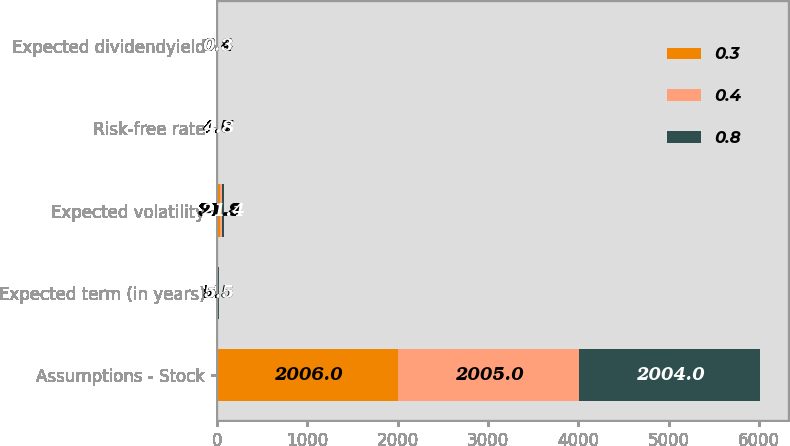Convert chart. <chart><loc_0><loc_0><loc_500><loc_500><stacked_bar_chart><ecel><fcel>Assumptions - Stock<fcel>Expected term (in years)<fcel>Expected volatility<fcel>Risk-free rate<fcel>Expected dividendyield<nl><fcel>0.3<fcel>2006<fcel>5.5<fcel>31.8<fcel>4.7<fcel>0.8<nl><fcel>0.4<fcel>2005<fcel>5.5<fcel>21.5<fcel>4.6<fcel>0.4<nl><fcel>0.8<fcel>2004<fcel>5.5<fcel>21.4<fcel>4.8<fcel>0.3<nl></chart> 